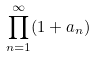Convert formula to latex. <formula><loc_0><loc_0><loc_500><loc_500>\prod _ { n = 1 } ^ { \infty } ( 1 + a _ { n } )</formula> 